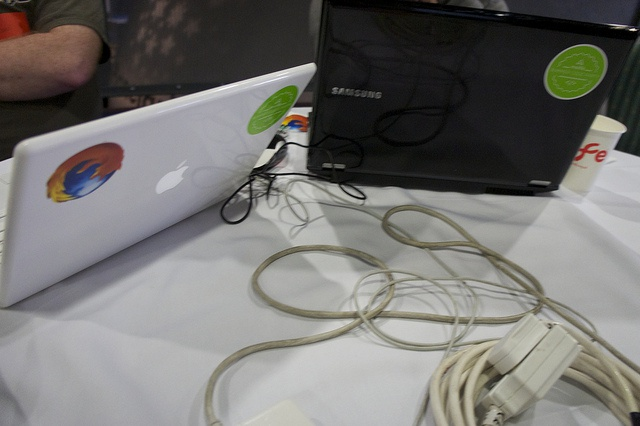Describe the objects in this image and their specific colors. I can see laptop in gray, black, darkgreen, and darkgray tones, laptop in gray, darkgray, lightgray, and maroon tones, people in black, maroon, brown, and gray tones, cup in gray, darkgray, tan, and brown tones, and cup in gray, darkgray, lightgray, and brown tones in this image. 